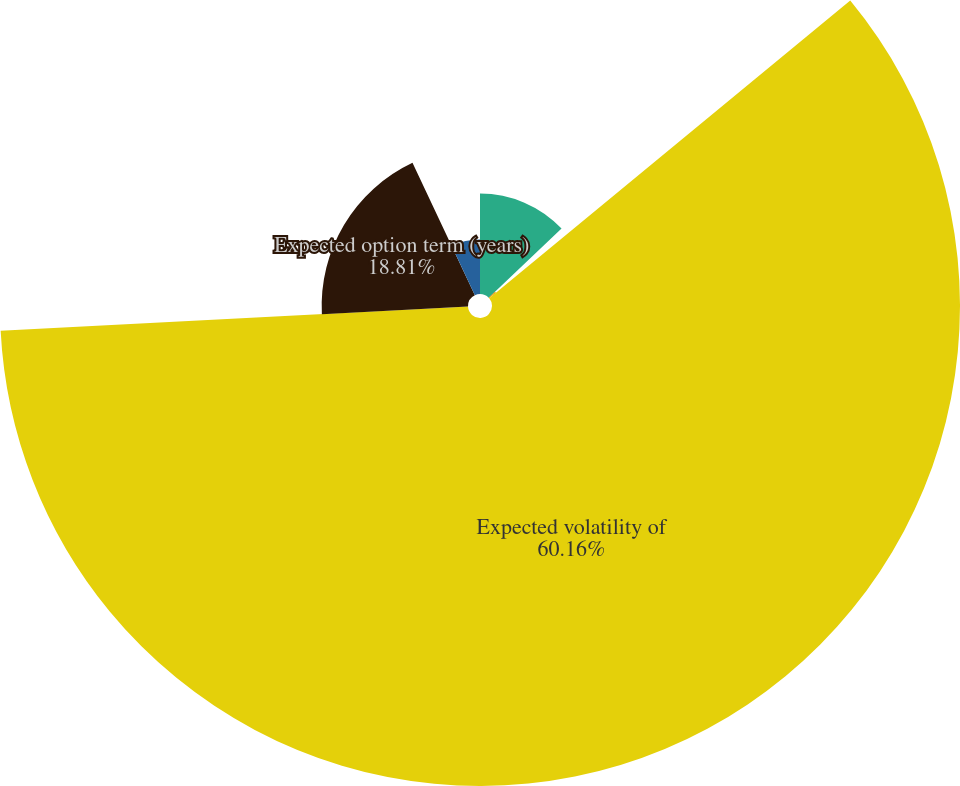<chart> <loc_0><loc_0><loc_500><loc_500><pie_chart><fcel>Risk-free interest rate<fcel>Expected dividend yield<fcel>Expected volatility of<fcel>Expected option term (years)<fcel>Weighted-average grant date<nl><fcel>12.91%<fcel>1.11%<fcel>60.15%<fcel>18.81%<fcel>7.01%<nl></chart> 